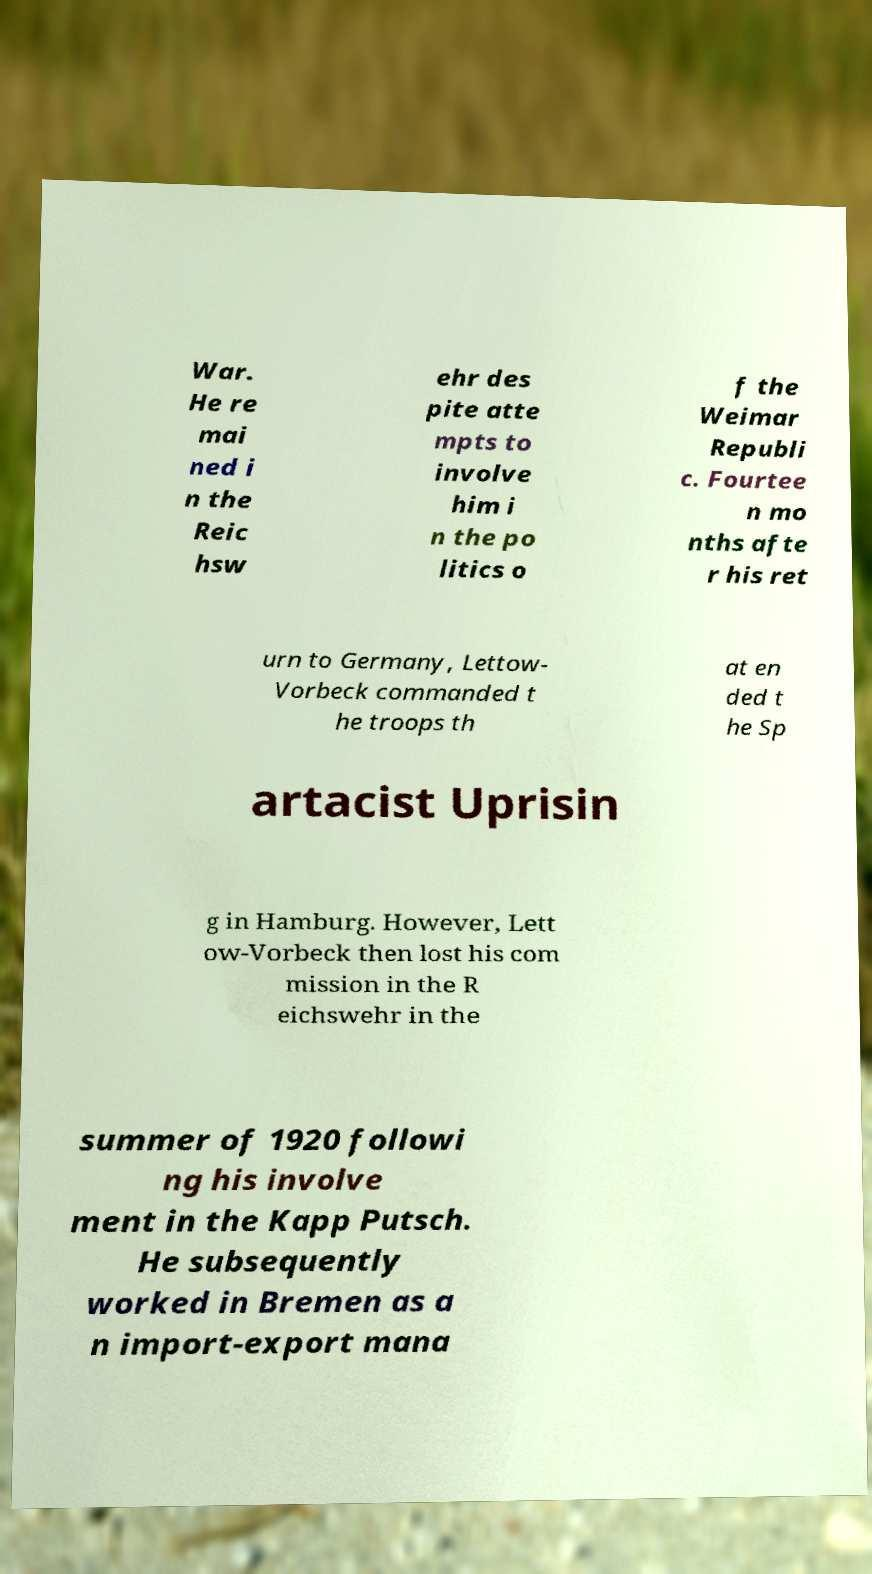What messages or text are displayed in this image? I need them in a readable, typed format. War. He re mai ned i n the Reic hsw ehr des pite atte mpts to involve him i n the po litics o f the Weimar Republi c. Fourtee n mo nths afte r his ret urn to Germany, Lettow- Vorbeck commanded t he troops th at en ded t he Sp artacist Uprisin g in Hamburg. However, Lett ow-Vorbeck then lost his com mission in the R eichswehr in the summer of 1920 followi ng his involve ment in the Kapp Putsch. He subsequently worked in Bremen as a n import-export mana 